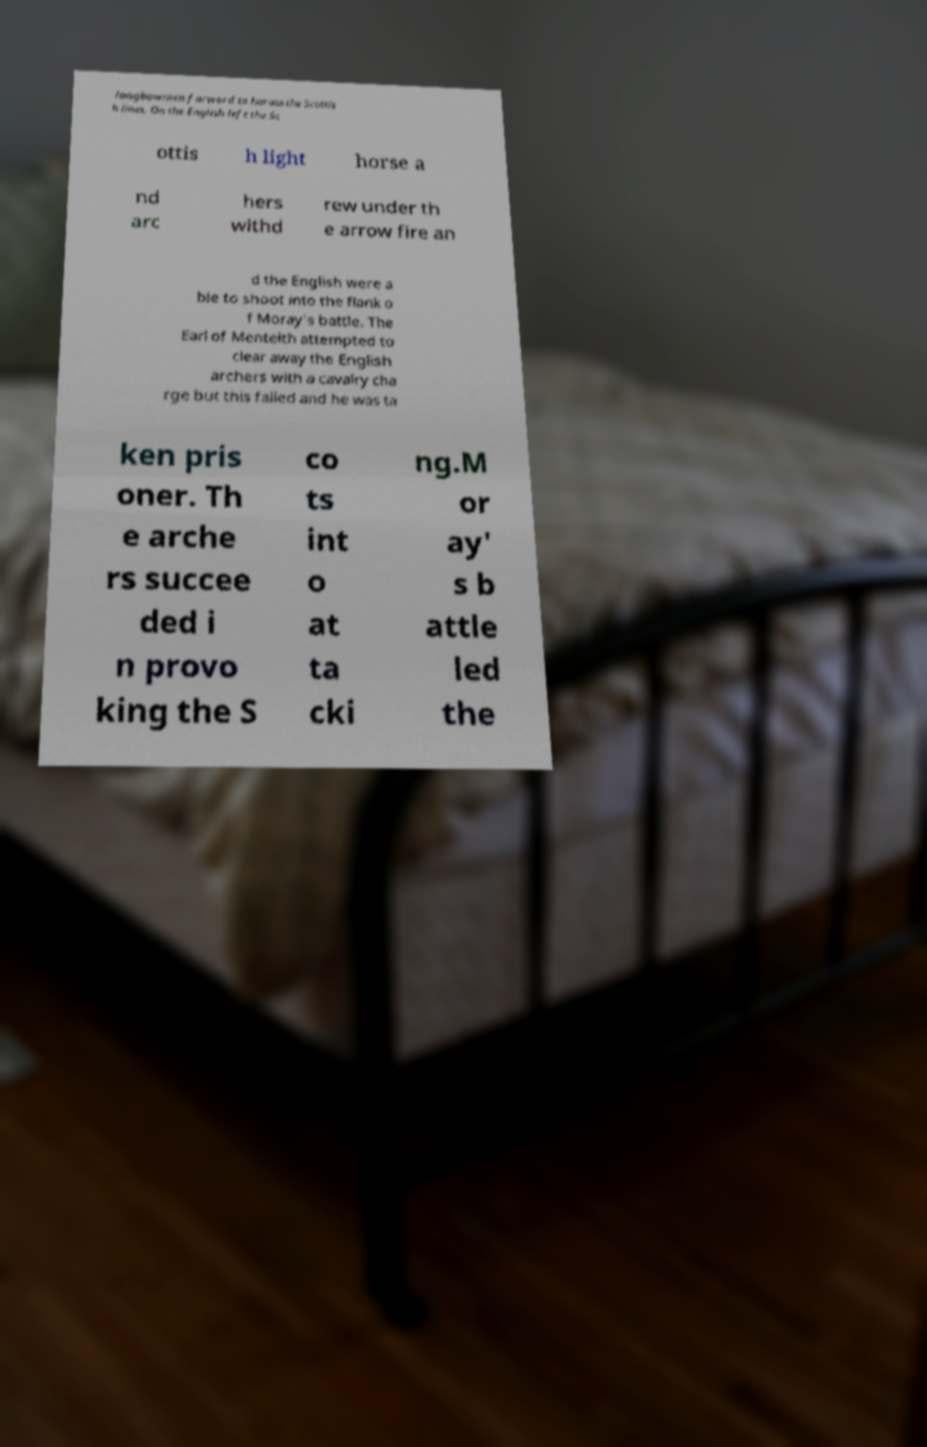Could you assist in decoding the text presented in this image and type it out clearly? longbowmen forward to harass the Scottis h lines. On the English left the Sc ottis h light horse a nd arc hers withd rew under th e arrow fire an d the English were a ble to shoot into the flank o f Moray's battle. The Earl of Menteith attempted to clear away the English archers with a cavalry cha rge but this failed and he was ta ken pris oner. Th e arche rs succee ded i n provo king the S co ts int o at ta cki ng.M or ay' s b attle led the 